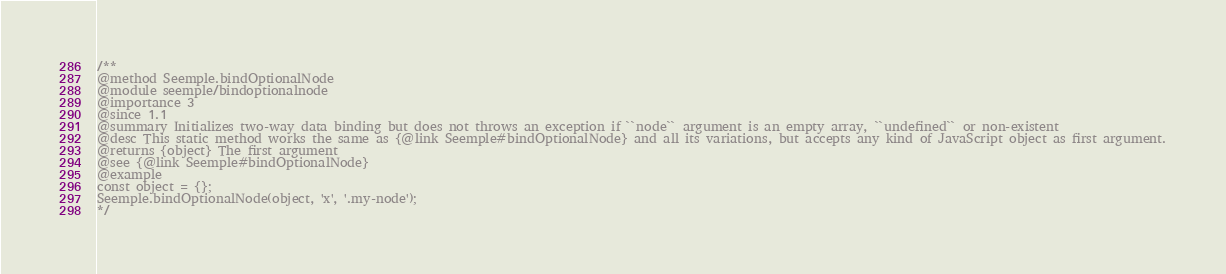Convert code to text. <code><loc_0><loc_0><loc_500><loc_500><_JavaScript_>/**
@method Seemple.bindOptionalNode
@module seemple/bindoptionalnode
@importance 3
@since 1.1
@summary Initializes two-way data binding but does not throws an exception if ``node`` argument is an empty array, ``undefined`` or non-existent
@desc This static method works the same as {@link Seemple#bindOptionalNode} and all its variations, but accepts any kind of JavaScript object as first argument.
@returns {object} The first argument
@see {@link Seemple#bindOptionalNode}
@example
const object = {};
Seemple.bindOptionalNode(object, 'x', '.my-node');
*/
</code> 